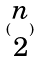Convert formula to latex. <formula><loc_0><loc_0><loc_500><loc_500>( \begin{matrix} n \\ 2 \end{matrix} )</formula> 